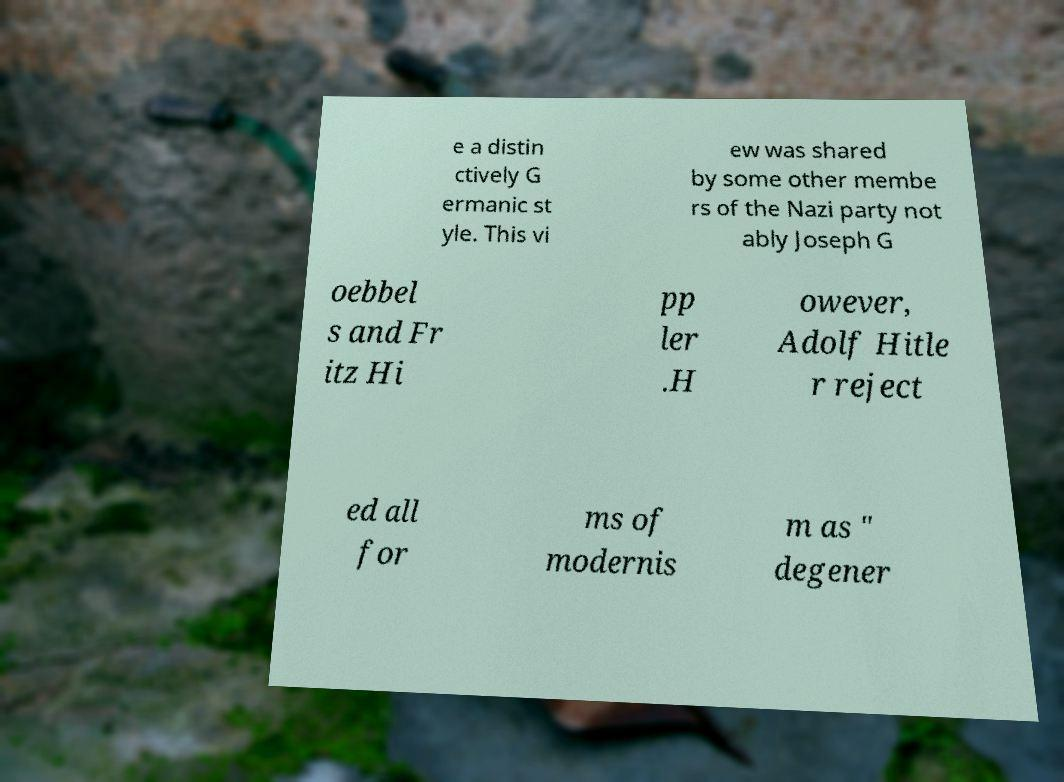Can you read and provide the text displayed in the image?This photo seems to have some interesting text. Can you extract and type it out for me? e a distin ctively G ermanic st yle. This vi ew was shared by some other membe rs of the Nazi party not ably Joseph G oebbel s and Fr itz Hi pp ler .H owever, Adolf Hitle r reject ed all for ms of modernis m as " degener 